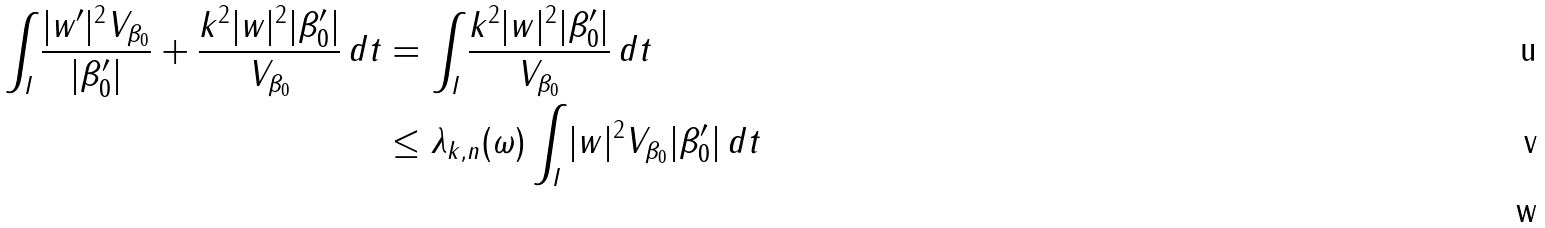<formula> <loc_0><loc_0><loc_500><loc_500>\int _ { I } \frac { | w ^ { \prime } | ^ { 2 } V _ { \beta _ { 0 } } } { | \beta _ { 0 } ^ { \prime } | } + \frac { k ^ { 2 } | w | ^ { 2 } | \beta _ { 0 } ^ { \prime } | } { V _ { \beta _ { 0 } } } \, d t & = \int _ { I } \frac { k ^ { 2 } | w | ^ { 2 } | \beta _ { 0 } ^ { \prime } | } { V _ { \beta _ { 0 } } } \, d t \\ & \leq \lambda _ { k , n } ( \omega ) \int _ { I } | w | ^ { 2 } V _ { \beta _ { 0 } } | \beta _ { 0 } ^ { \prime } | \, d t \\</formula> 